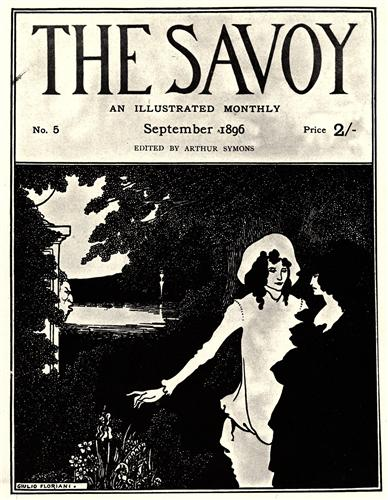What might be happening just outside the frame of this image? Just outside the frame, one can imagine the lush garden extending further, possibly leading to a larger estate or a grand Victorian house adorned with intricate architectural details emblematic of the period. Perhaps a gentle breeze rustles through the leaves, carrying the faint scent of blooming flowers and fresh earth. In the distance, there might be a path winding through the garden, inviting visitors to take a leisurely stroll or sit by the riverside, basking in the quietude of nature. 